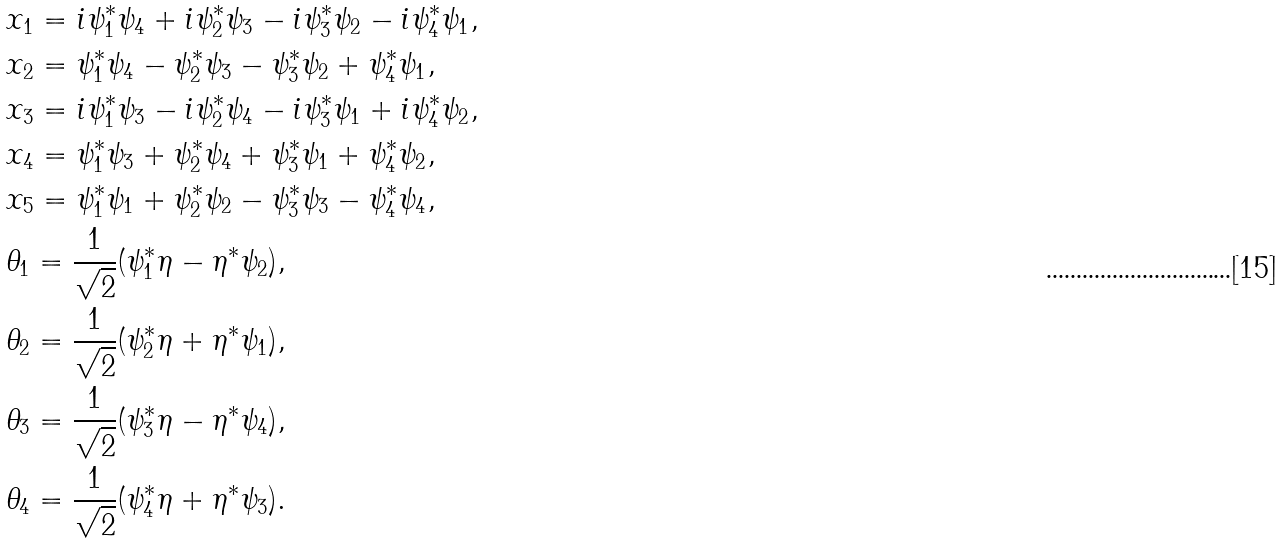Convert formula to latex. <formula><loc_0><loc_0><loc_500><loc_500>& x _ { 1 } = i \psi _ { 1 } ^ { * } \psi _ { 4 } + i \psi _ { 2 } ^ { * } \psi _ { 3 } - i \psi _ { 3 } ^ { * } \psi _ { 2 } - i \psi _ { 4 } ^ { * } \psi _ { 1 } , \\ & x _ { 2 } = \psi _ { 1 } ^ { * } \psi _ { 4 } - \psi _ { 2 } ^ { * } \psi _ { 3 } - \psi _ { 3 } ^ { * } \psi _ { 2 } + \psi _ { 4 } ^ { * } \psi _ { 1 } , \\ & x _ { 3 } = i \psi _ { 1 } ^ { * } \psi _ { 3 } - i \psi _ { 2 } ^ { * } \psi _ { 4 } - i \psi _ { 3 } ^ { * } \psi _ { 1 } + i \psi _ { 4 } ^ { * } \psi _ { 2 } , \\ & x _ { 4 } = \psi _ { 1 } ^ { * } \psi _ { 3 } + \psi _ { 2 } ^ { * } \psi _ { 4 } + \psi _ { 3 } ^ { * } \psi _ { 1 } + \psi _ { 4 } ^ { * } \psi _ { 2 } , \\ & x _ { 5 } = \psi _ { 1 } ^ { * } \psi _ { 1 } + \psi _ { 2 } ^ { * } \psi _ { 2 } - \psi _ { 3 } ^ { * } \psi _ { 3 } - \psi _ { 4 } ^ { * } \psi _ { 4 } , \\ & \theta _ { 1 } = \frac { 1 } { \sqrt { 2 } } ( \psi _ { 1 } ^ { * } \eta - \eta ^ { * } \psi _ { 2 } ) , \\ & \theta _ { 2 } = \frac { 1 } { \sqrt { 2 } } ( \psi _ { 2 } ^ { * } \eta + \eta ^ { * } \psi _ { 1 } ) , \\ & \theta _ { 3 } = \frac { 1 } { \sqrt { 2 } } ( \psi _ { 3 } ^ { * } \eta - \eta ^ { * } \psi _ { 4 } ) , \\ & \theta _ { 4 } = \frac { 1 } { \sqrt { 2 } } ( \psi _ { 4 } ^ { * } \eta + \eta ^ { * } \psi _ { 3 } ) .</formula> 